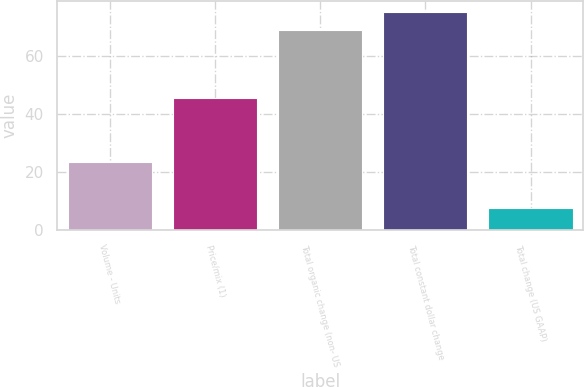Convert chart. <chart><loc_0><loc_0><loc_500><loc_500><bar_chart><fcel>Volume - Units<fcel>Price/mix (1)<fcel>Total organic change (non- US<fcel>Total constant dollar change<fcel>Total change (US GAAP)<nl><fcel>23.4<fcel>45.6<fcel>69<fcel>75.26<fcel>7.8<nl></chart> 